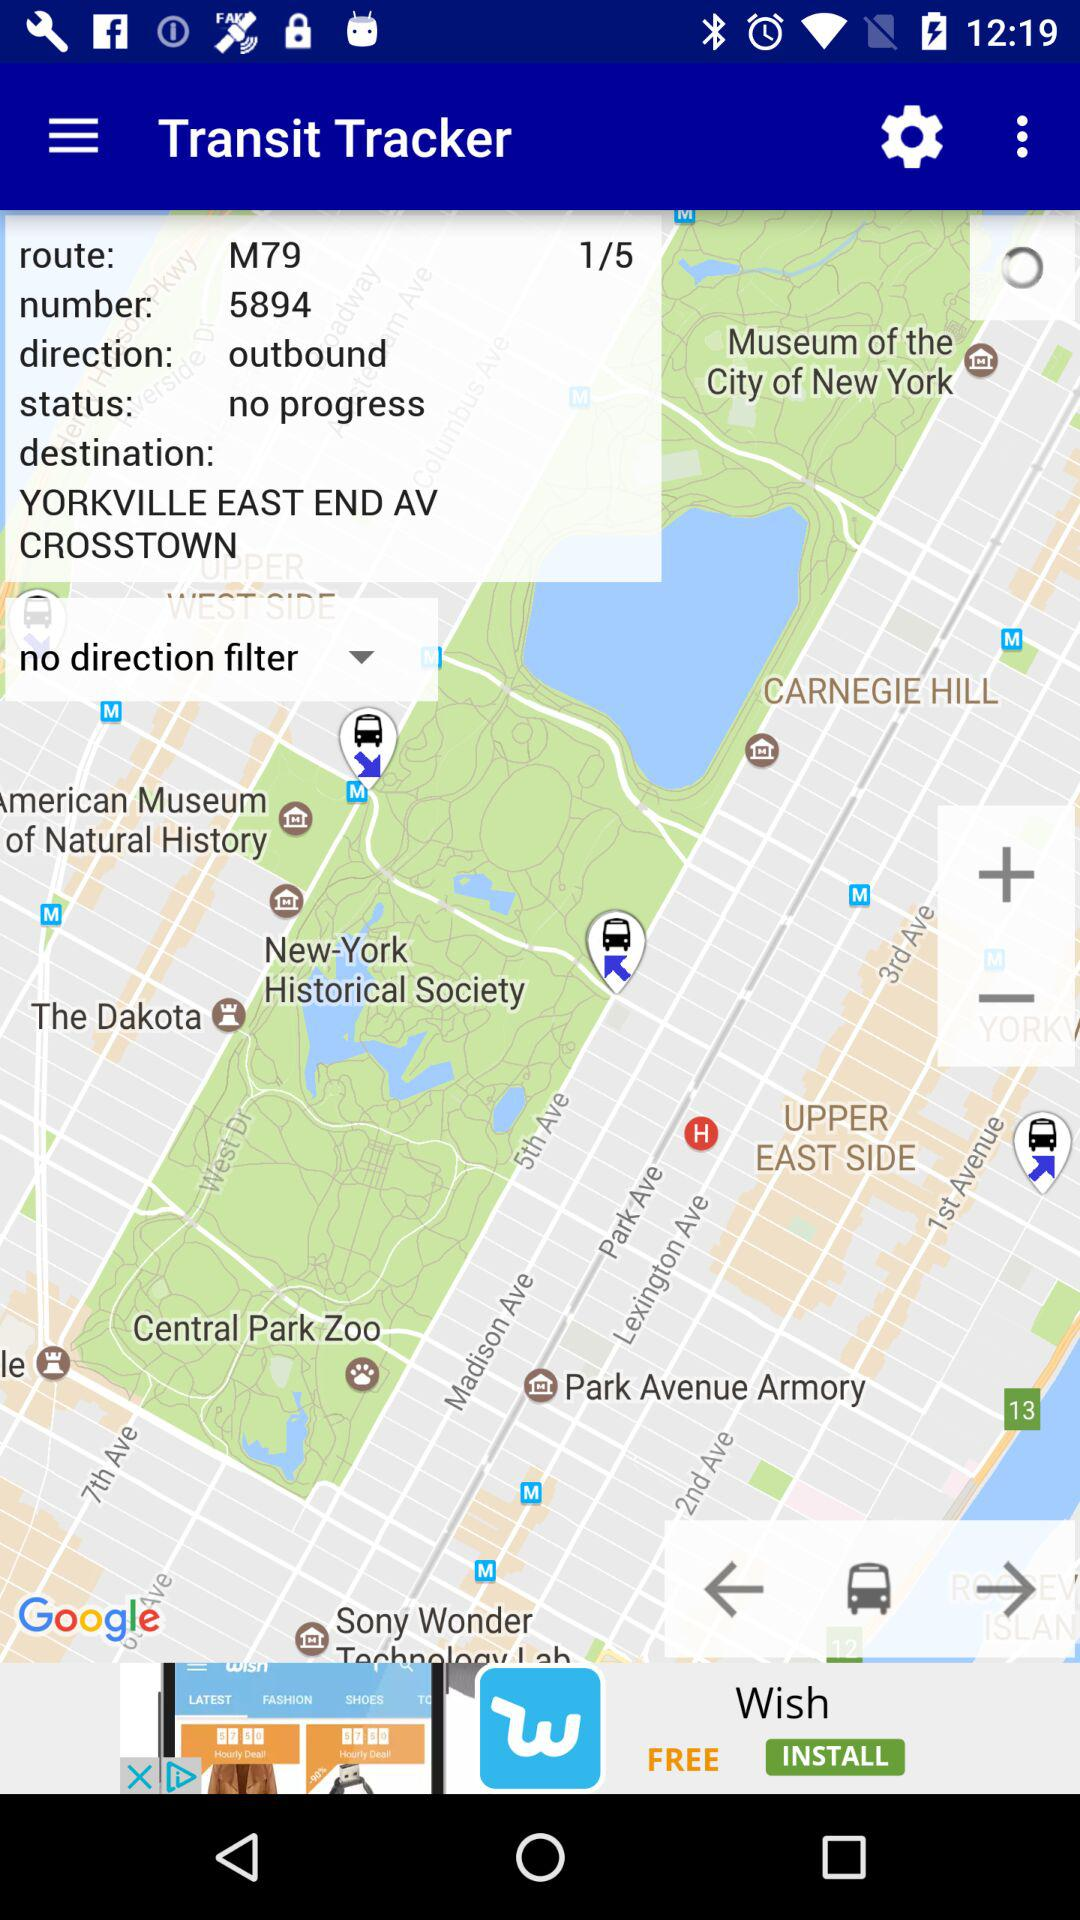What's the direction? The direction is "outbound". 